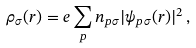Convert formula to latex. <formula><loc_0><loc_0><loc_500><loc_500>\rho _ { \sigma } ( { r } ) = e \sum _ { p } n _ { p \sigma } | \psi _ { p \sigma } ( { r } ) | ^ { 2 } \, ,</formula> 